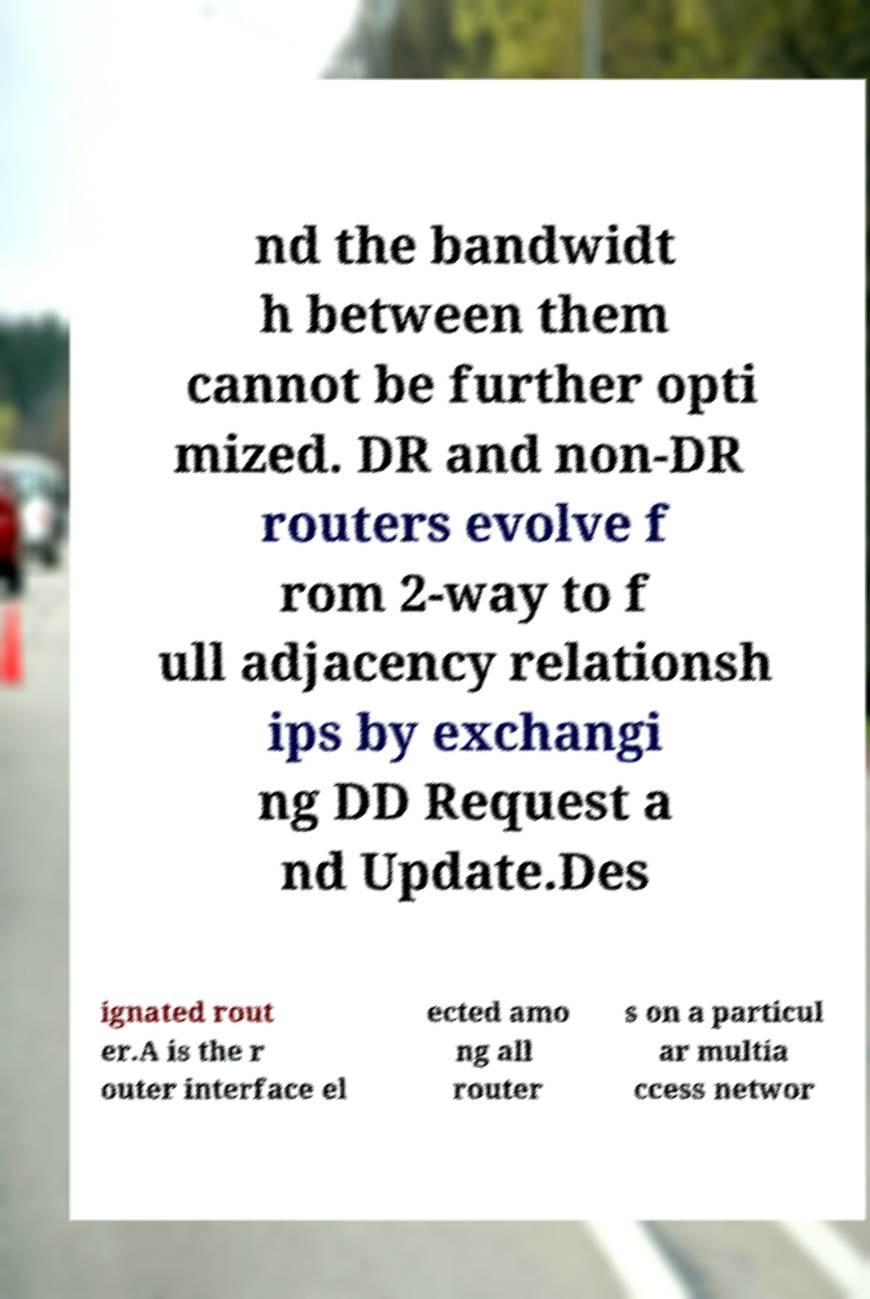What messages or text are displayed in this image? I need them in a readable, typed format. nd the bandwidt h between them cannot be further opti mized. DR and non-DR routers evolve f rom 2-way to f ull adjacency relationsh ips by exchangi ng DD Request a nd Update.Des ignated rout er.A is the r outer interface el ected amo ng all router s on a particul ar multia ccess networ 